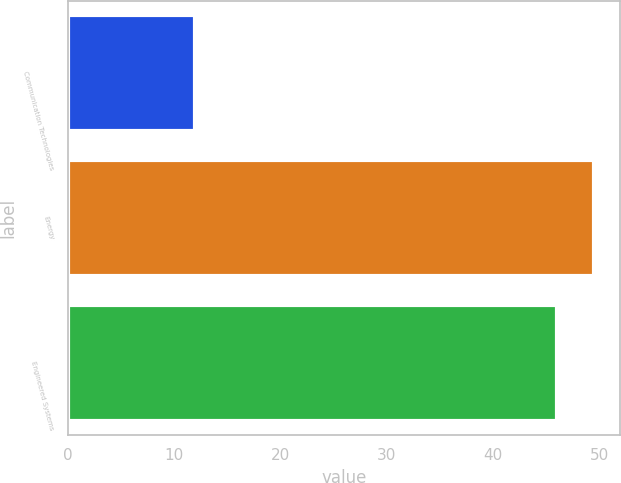<chart> <loc_0><loc_0><loc_500><loc_500><bar_chart><fcel>Communication Technologies<fcel>Energy<fcel>Engineered Systems<nl><fcel>12<fcel>49.5<fcel>46<nl></chart> 